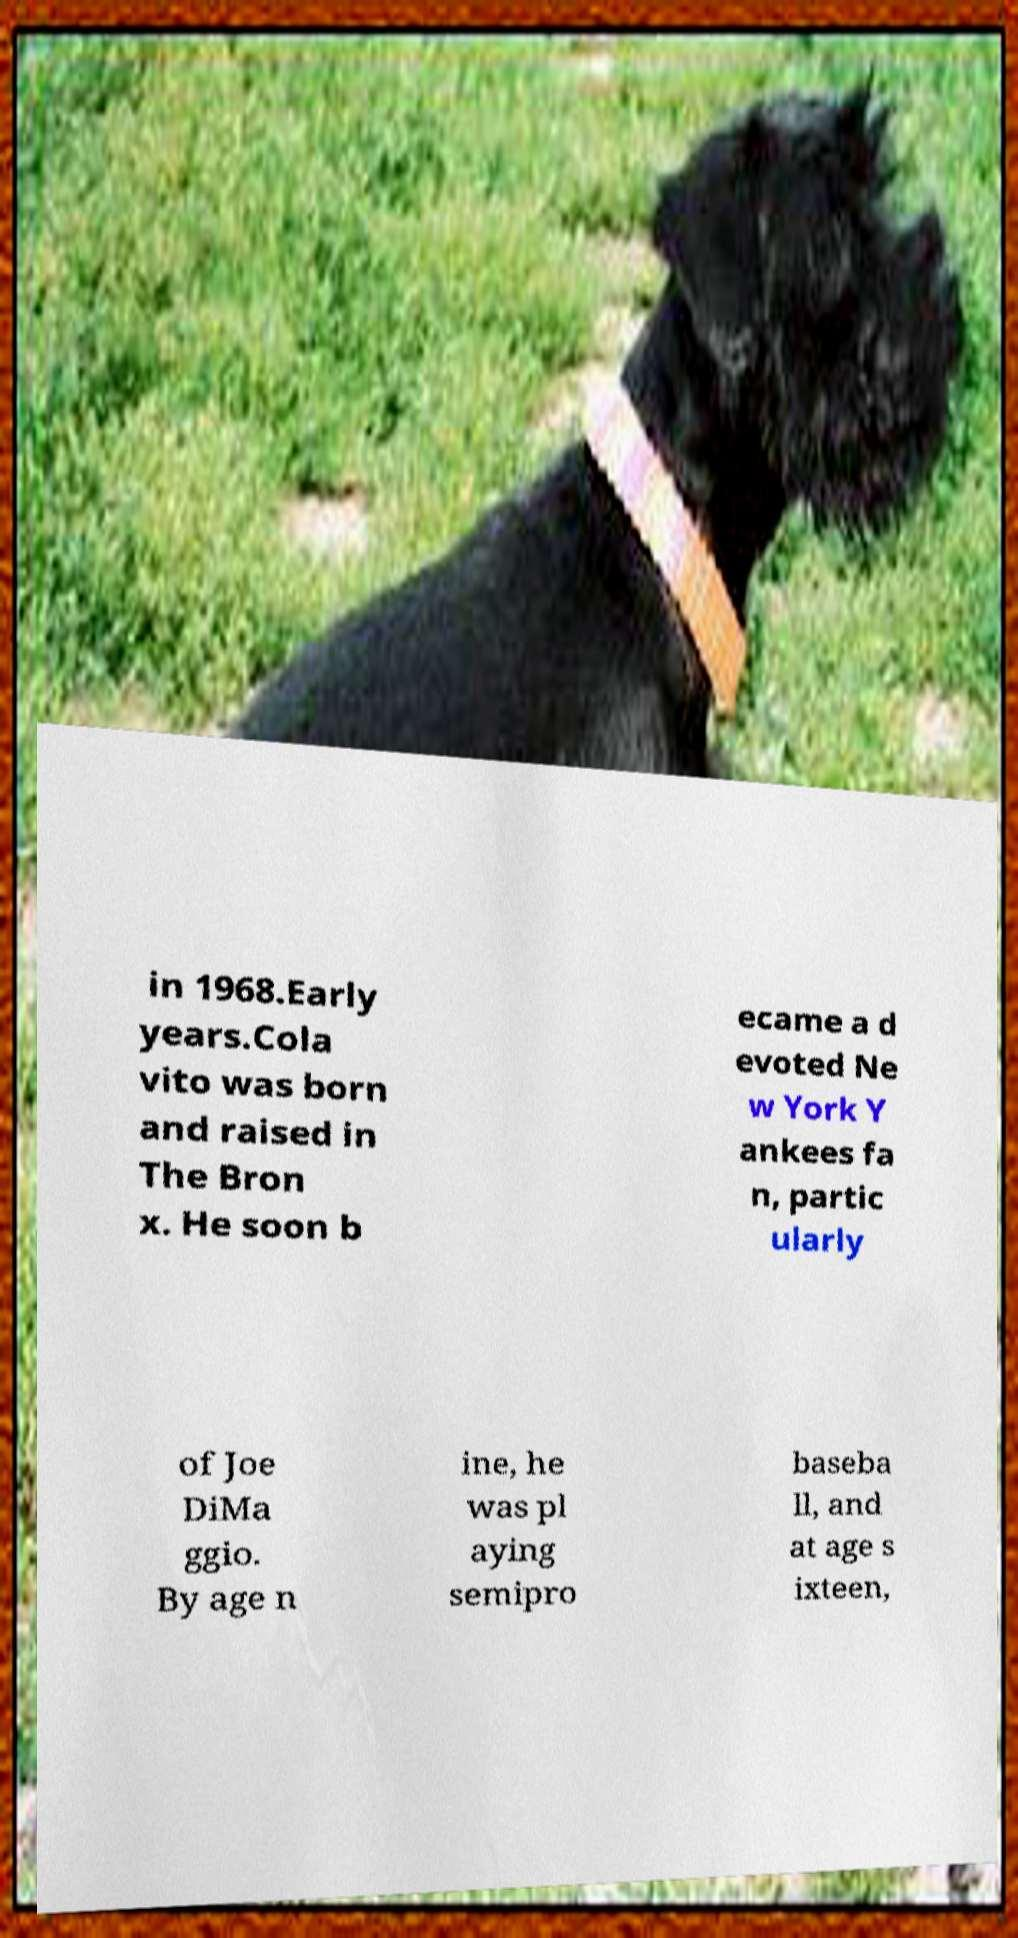What messages or text are displayed in this image? I need them in a readable, typed format. in 1968.Early years.Cola vito was born and raised in The Bron x. He soon b ecame a d evoted Ne w York Y ankees fa n, partic ularly of Joe DiMa ggio. By age n ine, he was pl aying semipro baseba ll, and at age s ixteen, 